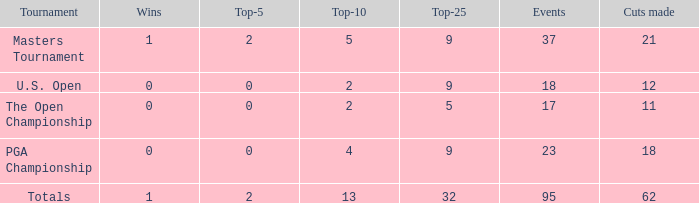What is the average number of cuts made in the Top 25 smaller than 5? None. 